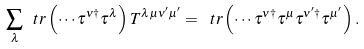<formula> <loc_0><loc_0><loc_500><loc_500>\sum _ { \lambda } \ t r \left ( \cdots \tau ^ { \nu \dagger } \tau ^ { \lambda } \right ) T ^ { \lambda \mu \nu ^ { \prime } \mu ^ { \prime } } = \ t r \left ( \cdots \tau ^ { \nu \dagger } \tau ^ { \mu } \tau ^ { \nu ^ { \prime } \dagger } \tau ^ { \mu ^ { \prime } } \right ) .</formula> 